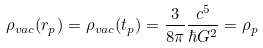Convert formula to latex. <formula><loc_0><loc_0><loc_500><loc_500>\rho _ { v a c } ( r _ { p } ) = \rho _ { v a c } ( t _ { p } ) = \frac { 3 } { 8 \pi } \frac { c ^ { 5 } } { \hbar { G } ^ { 2 } } = \rho _ { p }</formula> 